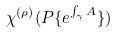<formula> <loc_0><loc_0><loc_500><loc_500>\chi ^ { ( \rho ) } ( P \{ e ^ { \int _ { \gamma } A } \} )</formula> 